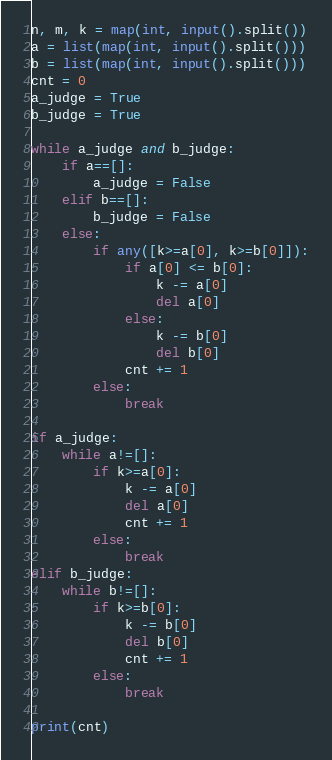<code> <loc_0><loc_0><loc_500><loc_500><_Python_>n, m, k = map(int, input().split())
a = list(map(int, input().split()))
b = list(map(int, input().split()))
cnt = 0
a_judge = True
b_judge = True

while a_judge and b_judge:
    if a==[]:
        a_judge = False
    elif b==[]:
        b_judge = False
    else:
        if any([k>=a[0], k>=b[0]]):
            if a[0] <= b[0]:
                k -= a[0]
                del a[0]
            else:
                k -= b[0]
                del b[0]
            cnt += 1
        else:
            break

if a_judge:
    while a!=[]:
        if k>=a[0]:
            k -= a[0]
            del a[0]
            cnt += 1
        else:
            break
elif b_judge:
    while b!=[]:
        if k>=b[0]:
            k -= b[0]
            del b[0]
            cnt += 1
        else:
            break

print(cnt)
</code> 